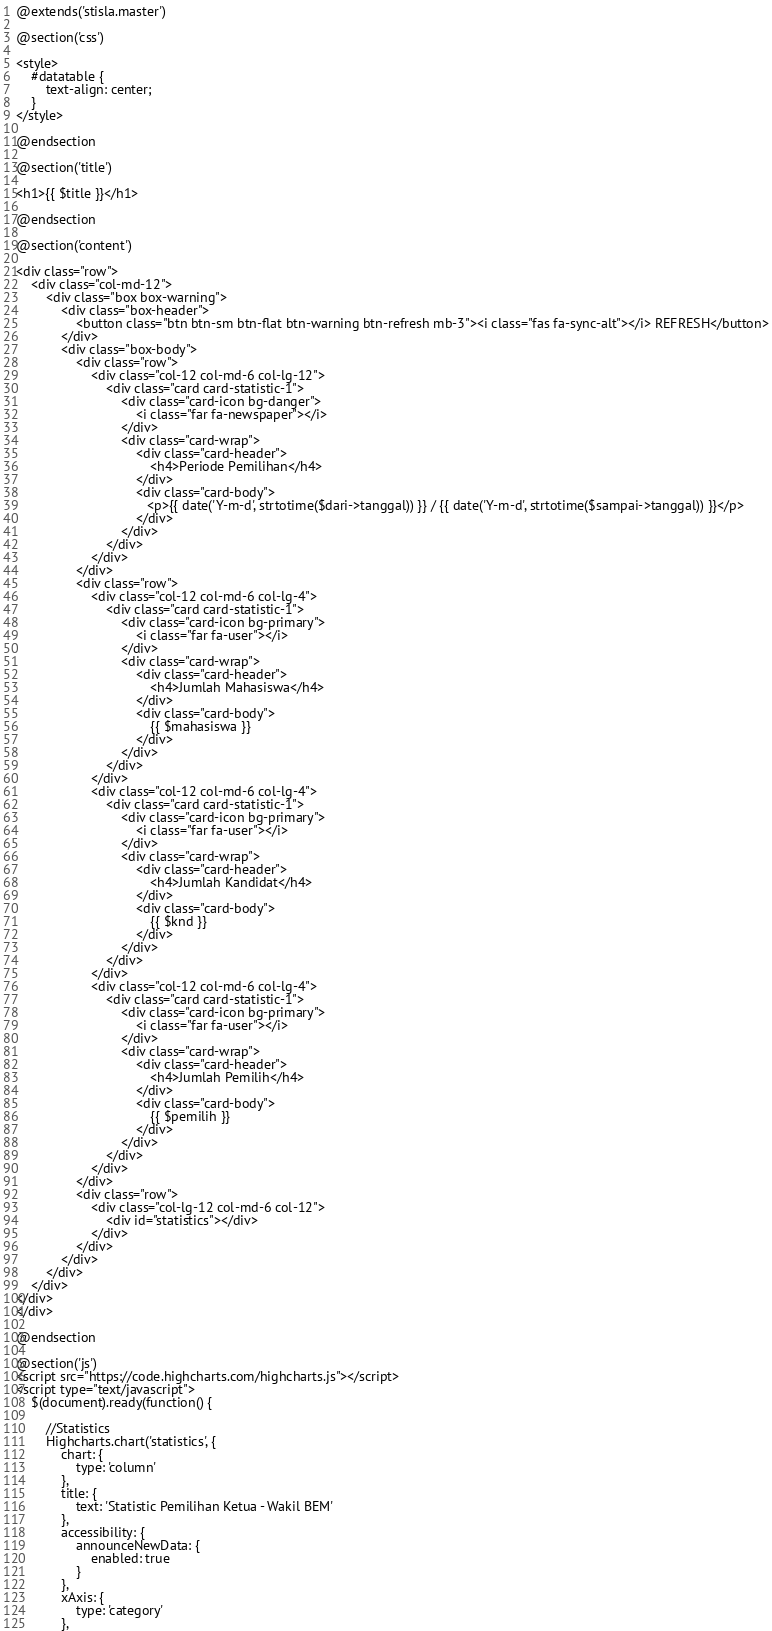Convert code to text. <code><loc_0><loc_0><loc_500><loc_500><_PHP_>@extends('stisla.master')

@section('css')

<style>
    #datatable {
        text-align: center;
    }
</style>

@endsection

@section('title')

<h1>{{ $title }}</h1>

@endsection

@section('content')

<div class="row">
    <div class="col-md-12">
        <div class="box box-warning">
            <div class="box-header">
                <button class="btn btn-sm btn-flat btn-warning btn-refresh mb-3"><i class="fas fa-sync-alt"></i> REFRESH</button>
            </div>
            <div class="box-body">
                <div class="row">
                    <div class="col-12 col-md-6 col-lg-12">
                        <div class="card card-statistic-1">
                            <div class="card-icon bg-danger">
                                <i class="far fa-newspaper"></i>
                            </div>
                            <div class="card-wrap">
                                <div class="card-header">
                                    <h4>Periode Pemilihan</h4>
                                </div>
                                <div class="card-body">
                                   <p>{{ date('Y-m-d', strtotime($dari->tanggal)) }} / {{ date('Y-m-d', strtotime($sampai->tanggal)) }}</p>
                                </div>
                            </div>
                        </div>
                    </div>
                </div>
                <div class="row">
                    <div class="col-12 col-md-6 col-lg-4">
                        <div class="card card-statistic-1">
                            <div class="card-icon bg-primary">
                                <i class="far fa-user"></i>
                            </div>
                            <div class="card-wrap">
                                <div class="card-header">
                                    <h4>Jumlah Mahasiswa</h4>
                                </div>
                                <div class="card-body">
                                    {{ $mahasiswa }}
                                </div>
                            </div>
                        </div>
                    </div>
                    <div class="col-12 col-md-6 col-lg-4">
                        <div class="card card-statistic-1">
                            <div class="card-icon bg-primary">
                                <i class="far fa-user"></i>
                            </div>
                            <div class="card-wrap">
                                <div class="card-header">
                                    <h4>Jumlah Kandidat</h4>
                                </div>
                                <div class="card-body">
                                    {{ $knd }}
                                </div>
                            </div>
                        </div>
                    </div>
                    <div class="col-12 col-md-6 col-lg-4">
                        <div class="card card-statistic-1">
                            <div class="card-icon bg-primary">
                                <i class="far fa-user"></i>
                            </div>
                            <div class="card-wrap">
                                <div class="card-header">
                                    <h4>Jumlah Pemilih</h4>
                                </div>
                                <div class="card-body">
                                    {{ $pemilih }}
                                </div>
                            </div>
                        </div>
                    </div>
                </div>
                <div class="row">
                    <div class="col-lg-12 col-md-6 col-12">
                        <div id="statistics"></div>
                    </div>
                </div>
            </div>
        </div>
    </div>
</div>
</div>

@endsection

@section('js')
<script src="https://code.highcharts.com/highcharts.js"></script>
<script type="text/javascript">
    $(document).ready(function() {

        //Statistics
        Highcharts.chart('statistics', {
            chart: {
                type: 'column'
            },
            title: {
                text: 'Statistic Pemilihan Ketua - Wakil BEM'
            },
            accessibility: {
                announceNewData: {
                    enabled: true
                }
            },
            xAxis: {
                type: 'category'
            },</code> 